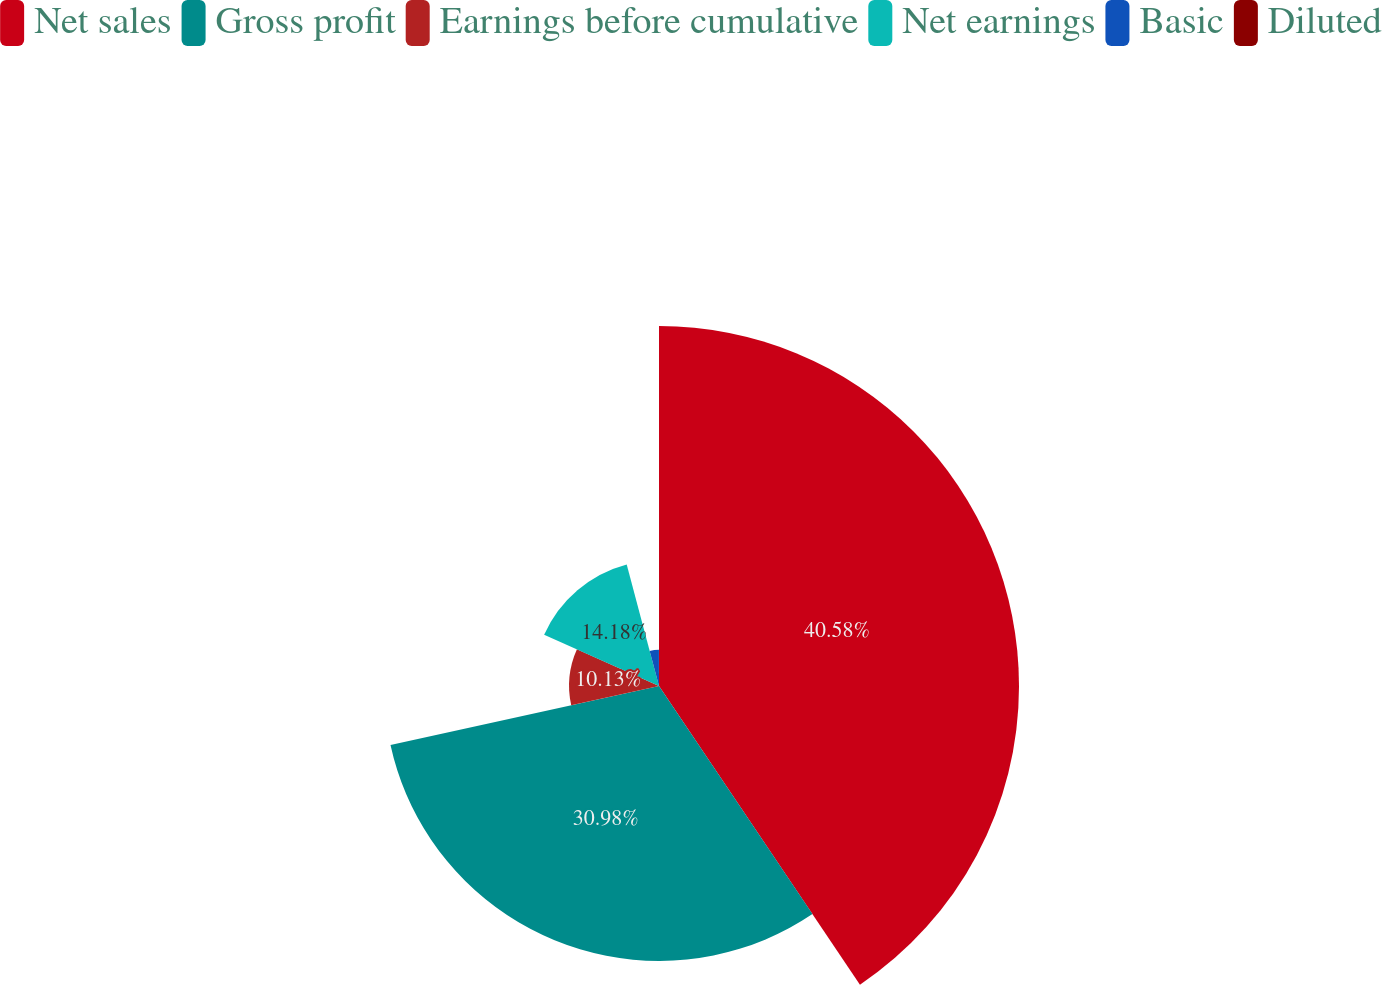<chart> <loc_0><loc_0><loc_500><loc_500><pie_chart><fcel>Net sales<fcel>Gross profit<fcel>Earnings before cumulative<fcel>Net earnings<fcel>Basic<fcel>Diluted<nl><fcel>40.57%<fcel>30.98%<fcel>10.13%<fcel>14.18%<fcel>4.09%<fcel>0.04%<nl></chart> 